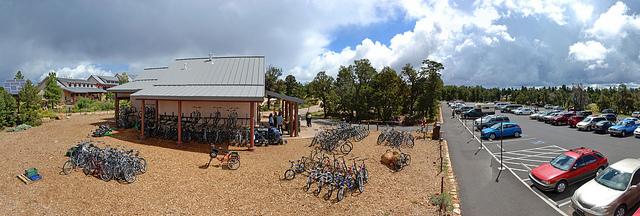Are there many or few bikes?
Give a very brief answer. Many. Is it going to rain soon?
Answer briefly. Yes. Is it likely that a number of the car owners are fans of the alternate form of vehicle shown here?
Answer briefly. Yes. 